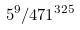<formula> <loc_0><loc_0><loc_500><loc_500>5 ^ { 9 } / 4 7 1 ^ { 3 2 5 }</formula> 